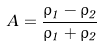<formula> <loc_0><loc_0><loc_500><loc_500>A = { \frac { \rho _ { 1 } - \rho _ { 2 } } { \rho _ { 1 } + \rho _ { 2 } } }</formula> 